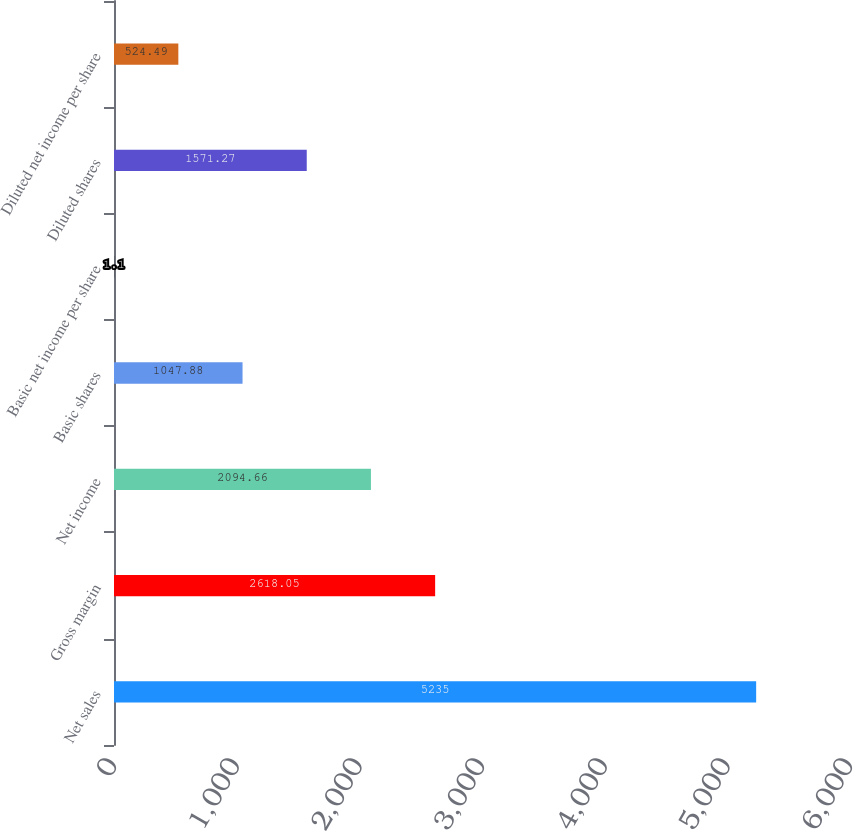Convert chart to OTSL. <chart><loc_0><loc_0><loc_500><loc_500><bar_chart><fcel>Net sales<fcel>Gross margin<fcel>Net income<fcel>Basic shares<fcel>Basic net income per share<fcel>Diluted shares<fcel>Diluted net income per share<nl><fcel>5235<fcel>2618.05<fcel>2094.66<fcel>1047.88<fcel>1.1<fcel>1571.27<fcel>524.49<nl></chart> 